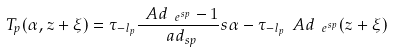Convert formula to latex. <formula><loc_0><loc_0><loc_500><loc_500>T _ { p } ( \alpha , z + \xi ) = \tau _ { - l _ { p } } \frac { \ A d _ { \ e ^ { s p } } - 1 } { \ a d _ { s p } } s \alpha - \tau _ { - l _ { p } } \ A d _ { \ e ^ { s p } } ( z + \xi )</formula> 